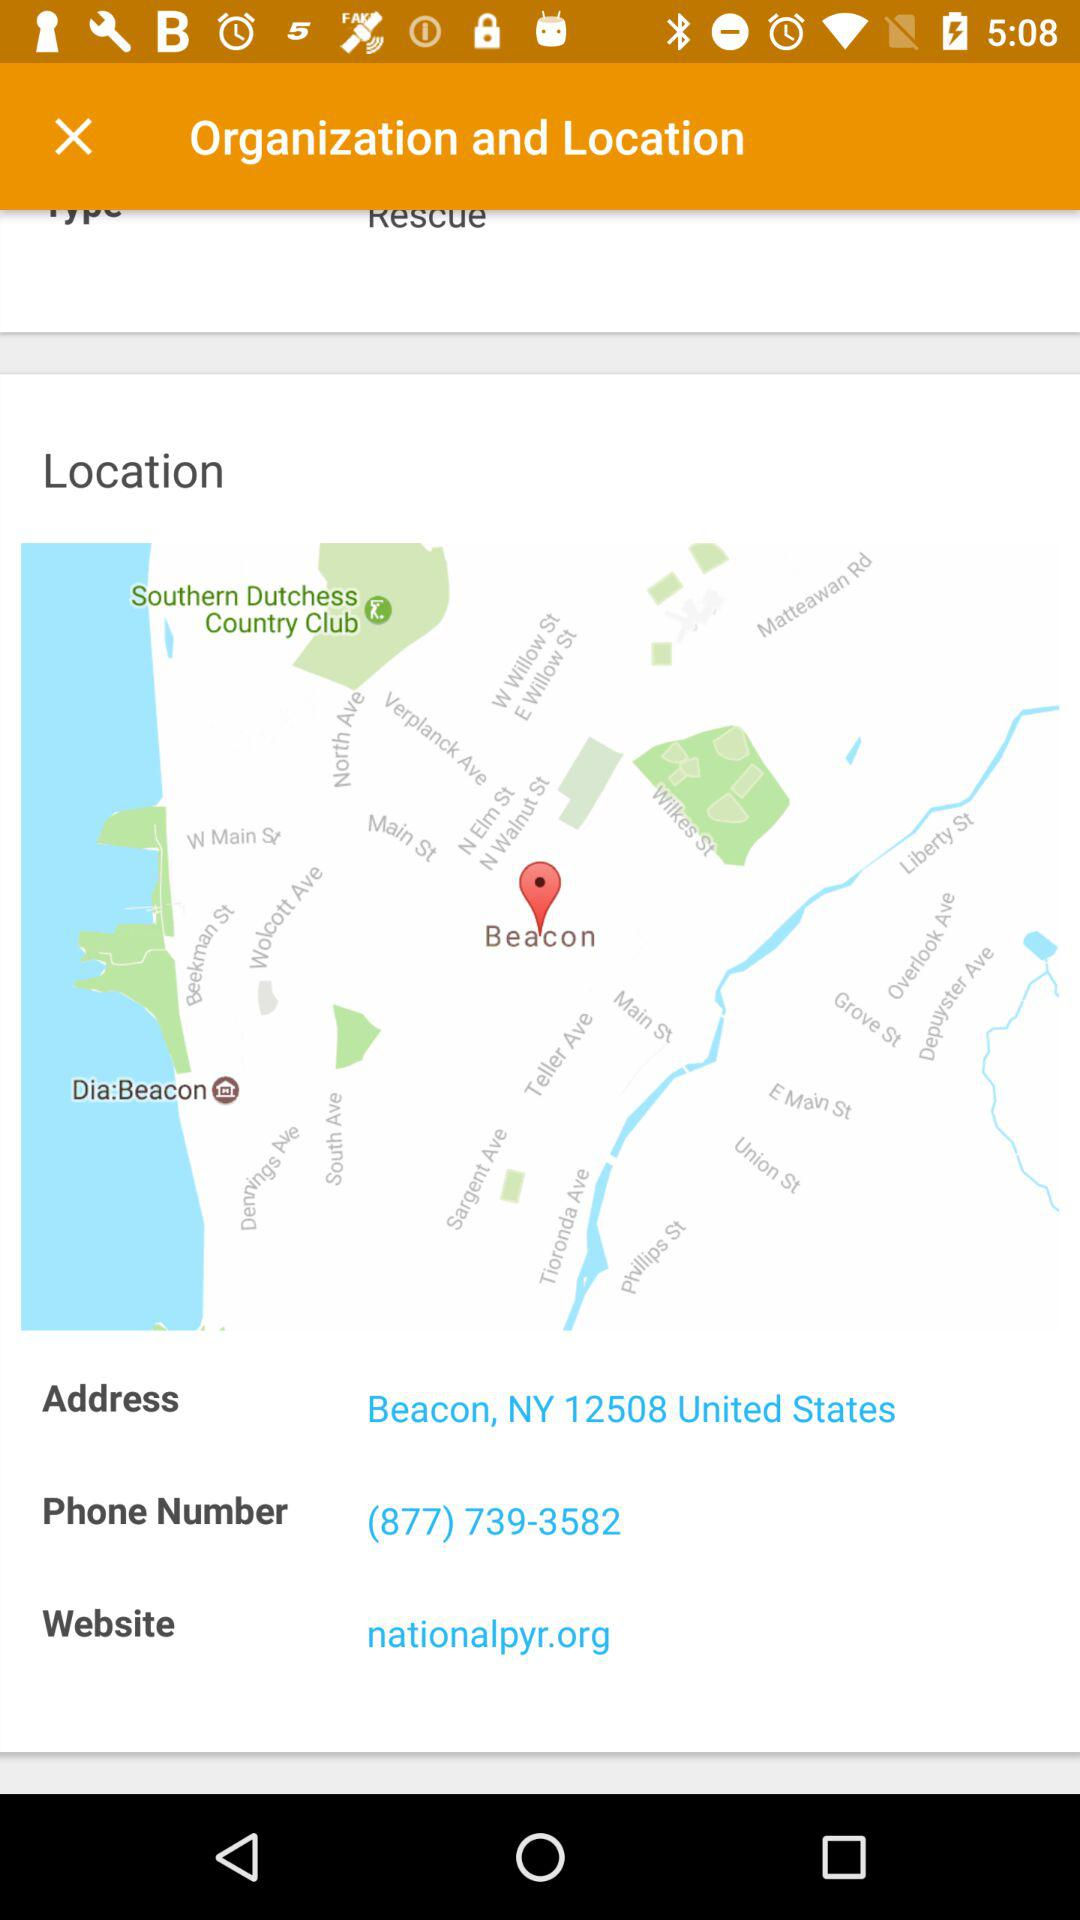What is the given address? The given address is Beacon, NY 12508, United States. 